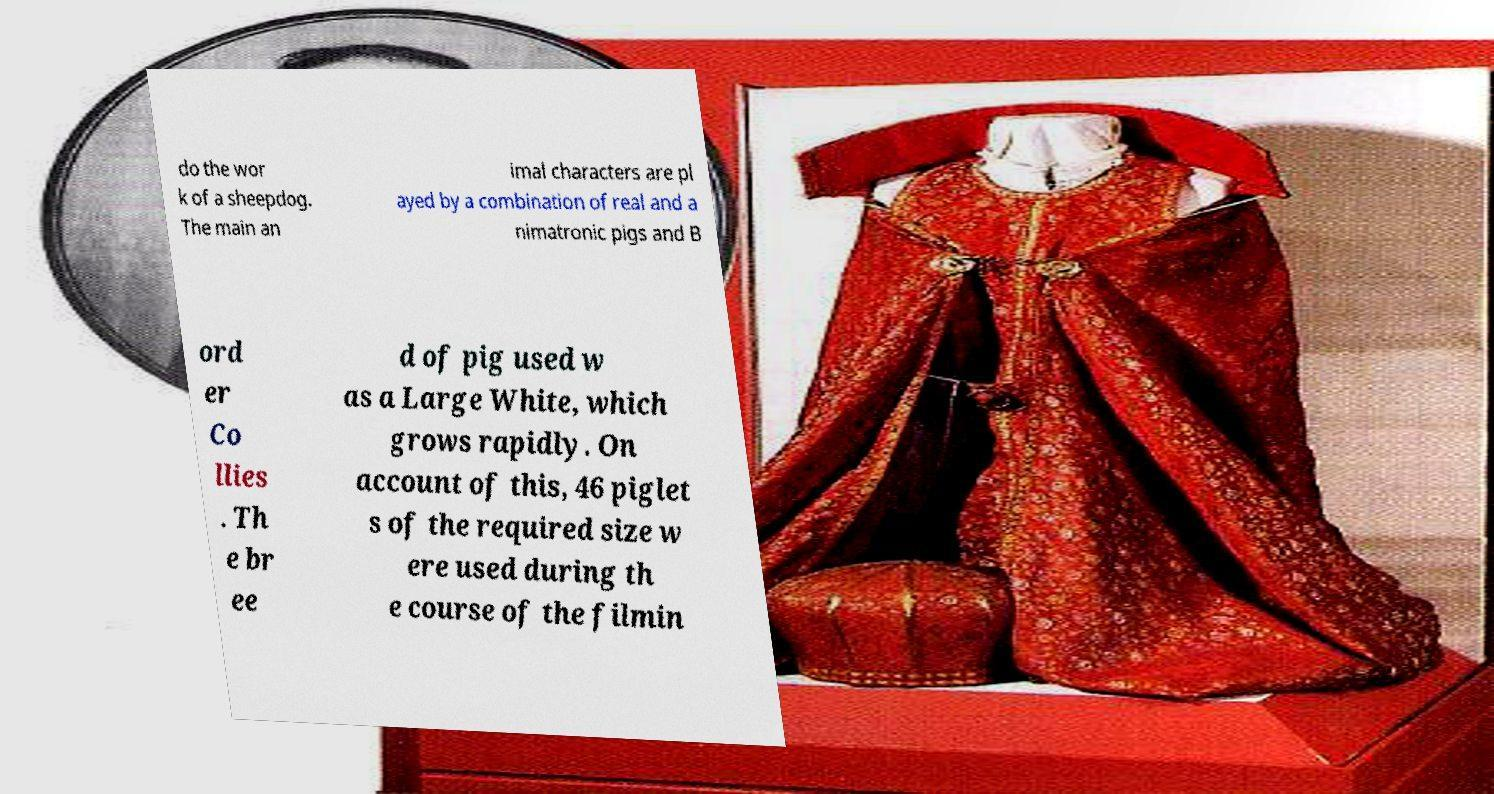Could you extract and type out the text from this image? do the wor k of a sheepdog. The main an imal characters are pl ayed by a combination of real and a nimatronic pigs and B ord er Co llies . Th e br ee d of pig used w as a Large White, which grows rapidly. On account of this, 46 piglet s of the required size w ere used during th e course of the filmin 